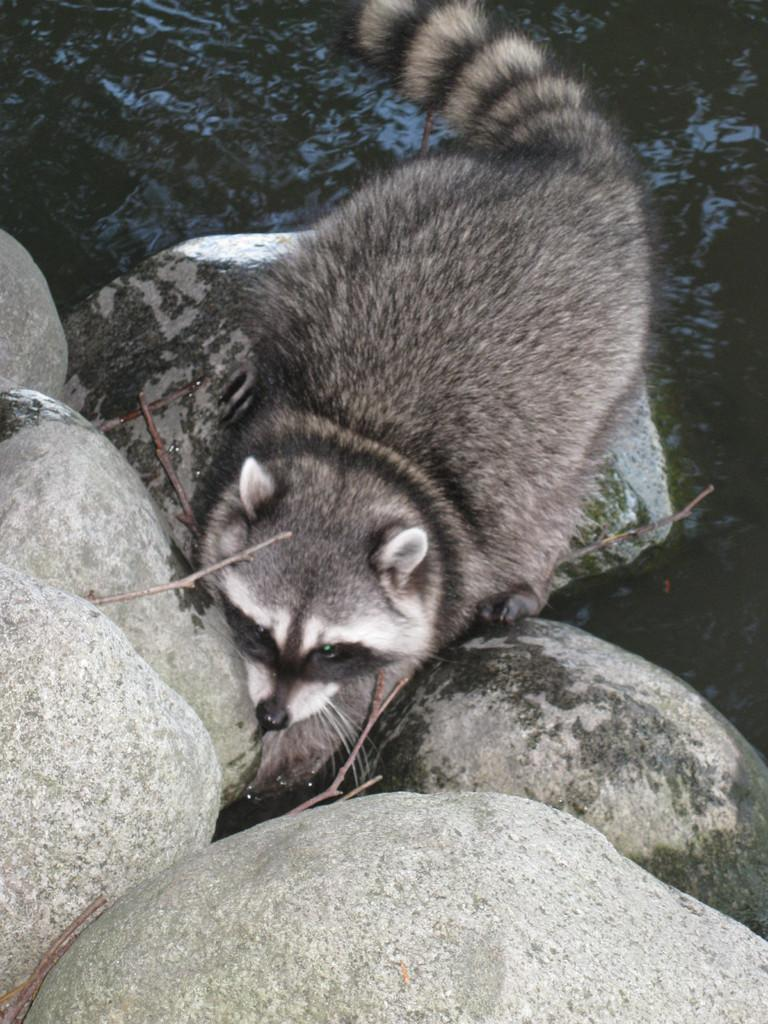What type of animal can be seen in the image? There is an animal in the image, but its specific type cannot be determined from the provided facts. What colors are present on the animal in the image? The animal is in grey and white color. Where is the animal located in the image? The animal is on the rocks. What can be seen in the background of the image? There is water visible in the background of the image. What type of acoustics can be heard from the animal in the image? There is no information about the animal's acoustics in the image, so it cannot be determined. How small is the minute detail on the animal's fur in the image? There is no mention of any minute details on the animal's fur in the image, so it cannot be determined. 